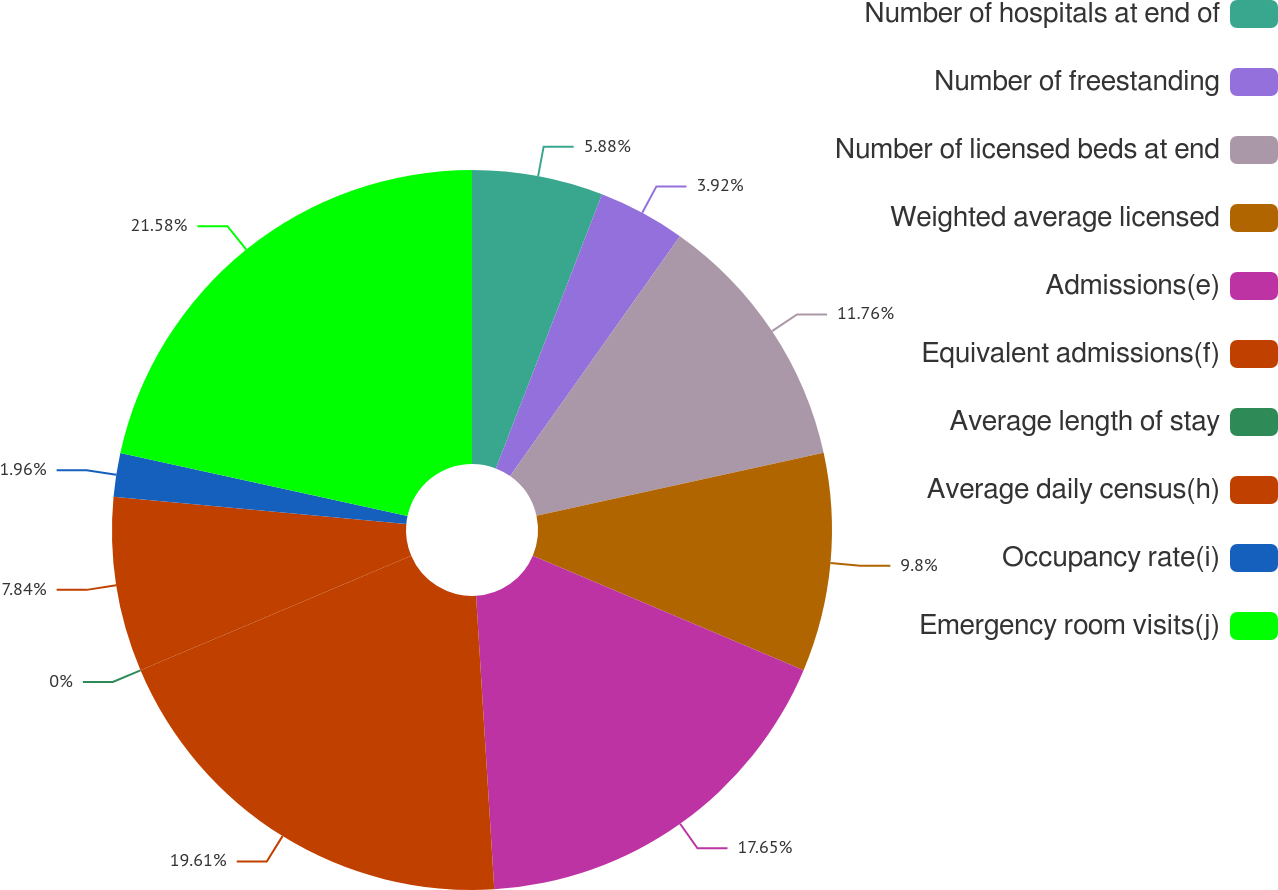Convert chart to OTSL. <chart><loc_0><loc_0><loc_500><loc_500><pie_chart><fcel>Number of hospitals at end of<fcel>Number of freestanding<fcel>Number of licensed beds at end<fcel>Weighted average licensed<fcel>Admissions(e)<fcel>Equivalent admissions(f)<fcel>Average length of stay<fcel>Average daily census(h)<fcel>Occupancy rate(i)<fcel>Emergency room visits(j)<nl><fcel>5.88%<fcel>3.92%<fcel>11.76%<fcel>9.8%<fcel>17.65%<fcel>19.61%<fcel>0.0%<fcel>7.84%<fcel>1.96%<fcel>21.57%<nl></chart> 